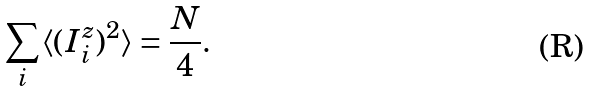Convert formula to latex. <formula><loc_0><loc_0><loc_500><loc_500>\sum _ { i } \langle ( I _ { i } ^ { z } ) ^ { 2 } \rangle = \frac { N } { 4 } .</formula> 